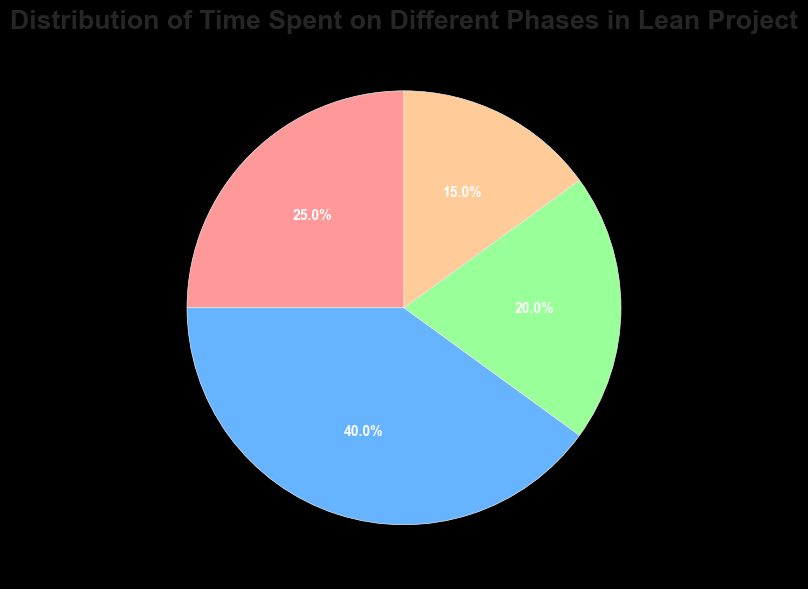What phase takes up the largest time percentage in the lean project? By observing the pie chart, the 'Implementation' phase occupies the largest segment of the pie, which is indicated to be 40%.
Answer: Implementation Which two phases combined account for a greater percentage than the 'Implementation' phase alone? The 'Planning' phase (25%) and the 'Review' phase (20%) together account for 45%, which is greater than the 40% for the 'Implementation' phase.
Answer: Planning and Review What percentage of time is spent on non-implementation phases? By adding the time percentages for the 'Planning' (25%), 'Review' (20%), and 'Improvement' (15%) phases, we get 25% + 20% + 15% = 60%.
Answer: 60% What is the difference in percentage between the time spent on 'Planning' and 'Improvement'? Subtract the percentage for 'Improvement' (15%) from 'Planning' (25%), resulting in 25% - 15% = 10%.
Answer: 10% Which phases collectively account for less than half of the time spent on the project? Adding the percentages for 'Review' (20%) and 'Improvement' (15%) together results in 20% + 15% = 35%, which is less than 50%.
Answer: Review and Improvement If the total project time is 100 hours, how many hours are spent on the 'Review' phase? Given that 'Review' takes up 20%, we calculate 20% of 100 hours, which is (20/100) * 100 = 20 hours.
Answer: 20 hours Which phase is represented by the green section of the pie chart? According to the pie chart, the 'Review' phase is represented in green.
Answer: Review How many phases each take up more than 20% of the total time? Observing the pie chart, 'Planning' (25%) and 'Implementation' (40%) both take up more than 20% each.
Answer: 2 What is the combined percentage for the phases occupying the smallest and the largest slices of the pie chart? The smallest slice is 'Improvement' (15%) and the largest is 'Implementation' (40%). Their combined percentage is 15% + 40% = 55%.
Answer: 55% If the project time is reduced by half, what will be the new time spent on the 'Improvement' phase? If the project time is now 50 hours (half of 100), we calculate 15% of 50 hours for the 'Improvement' phase, which is (15/100) * 50 = 7.5 hours.
Answer: 7.5 hours 